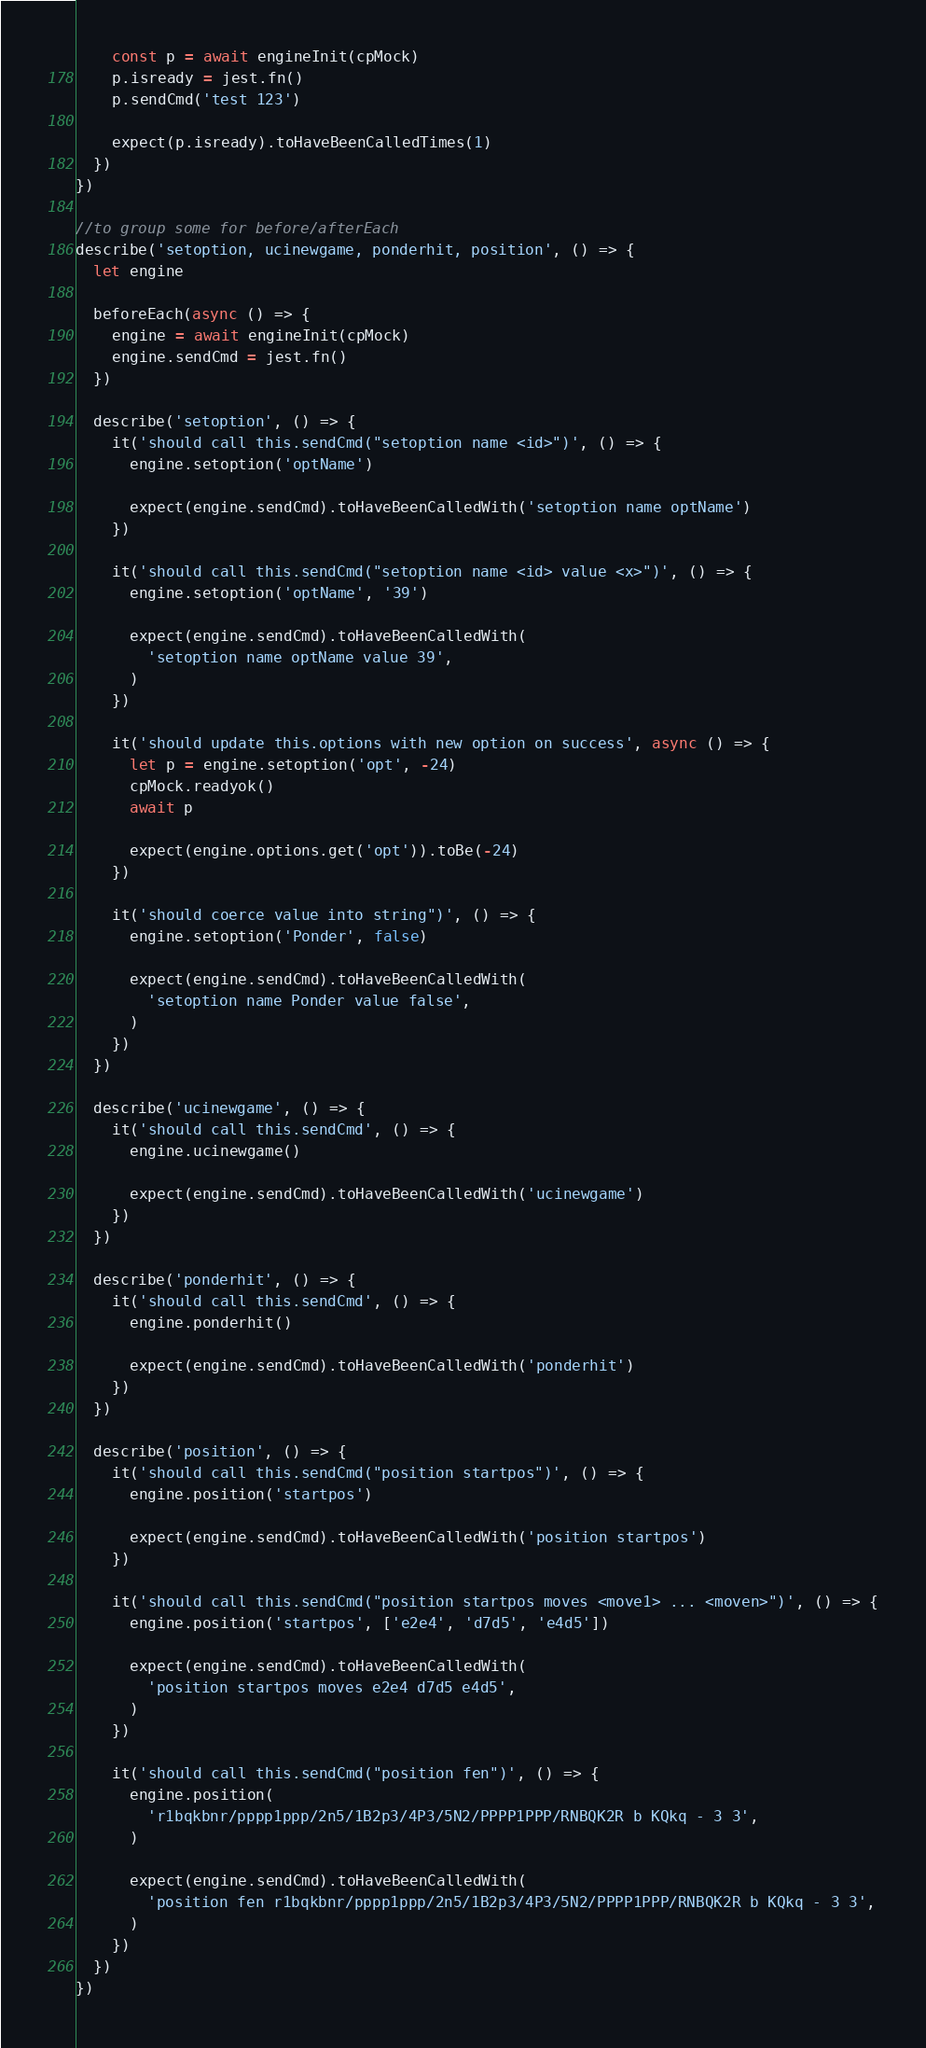<code> <loc_0><loc_0><loc_500><loc_500><_JavaScript_>    const p = await engineInit(cpMock)
    p.isready = jest.fn()
    p.sendCmd('test 123')

    expect(p.isready).toHaveBeenCalledTimes(1)
  })
})

//to group some for before/afterEach
describe('setoption, ucinewgame, ponderhit, position', () => {
  let engine

  beforeEach(async () => {
    engine = await engineInit(cpMock)
    engine.sendCmd = jest.fn()
  })

  describe('setoption', () => {
    it('should call this.sendCmd("setoption name <id>")', () => {
      engine.setoption('optName')

      expect(engine.sendCmd).toHaveBeenCalledWith('setoption name optName')
    })

    it('should call this.sendCmd("setoption name <id> value <x>")', () => {
      engine.setoption('optName', '39')

      expect(engine.sendCmd).toHaveBeenCalledWith(
        'setoption name optName value 39',
      )
    })

    it('should update this.options with new option on success', async () => {
      let p = engine.setoption('opt', -24)
      cpMock.readyok()
      await p

      expect(engine.options.get('opt')).toBe(-24)
    })

    it('should coerce value into string")', () => {
      engine.setoption('Ponder', false)

      expect(engine.sendCmd).toHaveBeenCalledWith(
        'setoption name Ponder value false',
      )
    })
  })

  describe('ucinewgame', () => {
    it('should call this.sendCmd', () => {
      engine.ucinewgame()

      expect(engine.sendCmd).toHaveBeenCalledWith('ucinewgame')
    })
  })

  describe('ponderhit', () => {
    it('should call this.sendCmd', () => {
      engine.ponderhit()

      expect(engine.sendCmd).toHaveBeenCalledWith('ponderhit')
    })
  })

  describe('position', () => {
    it('should call this.sendCmd("position startpos")', () => {
      engine.position('startpos')

      expect(engine.sendCmd).toHaveBeenCalledWith('position startpos')
    })

    it('should call this.sendCmd("position startpos moves <move1> ... <moven>")', () => {
      engine.position('startpos', ['e2e4', 'd7d5', 'e4d5'])

      expect(engine.sendCmd).toHaveBeenCalledWith(
        'position startpos moves e2e4 d7d5 e4d5',
      )
    })

    it('should call this.sendCmd("position fen")', () => {
      engine.position(
        'r1bqkbnr/pppp1ppp/2n5/1B2p3/4P3/5N2/PPPP1PPP/RNBQK2R b KQkq - 3 3',
      )

      expect(engine.sendCmd).toHaveBeenCalledWith(
        'position fen r1bqkbnr/pppp1ppp/2n5/1B2p3/4P3/5N2/PPPP1PPP/RNBQK2R b KQkq - 3 3',
      )
    })
  })
})
</code> 